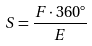Convert formula to latex. <formula><loc_0><loc_0><loc_500><loc_500>S = \frac { F \cdot 3 6 0 ^ { \circ } } { E }</formula> 